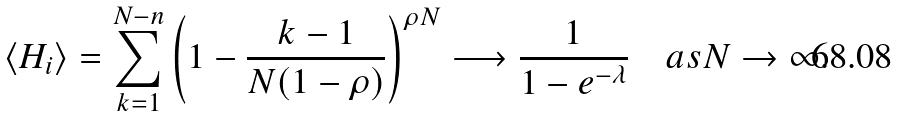Convert formula to latex. <formula><loc_0><loc_0><loc_500><loc_500>\langle H _ { i } \rangle = \sum _ { k = 1 } ^ { N - n } \left ( 1 - { \frac { k - 1 } { N ( 1 - \rho ) } } \right ) ^ { \rho N } \longrightarrow { \frac { 1 } { 1 - e ^ { - \lambda } } } \quad { a s } N \to \infty .</formula> 